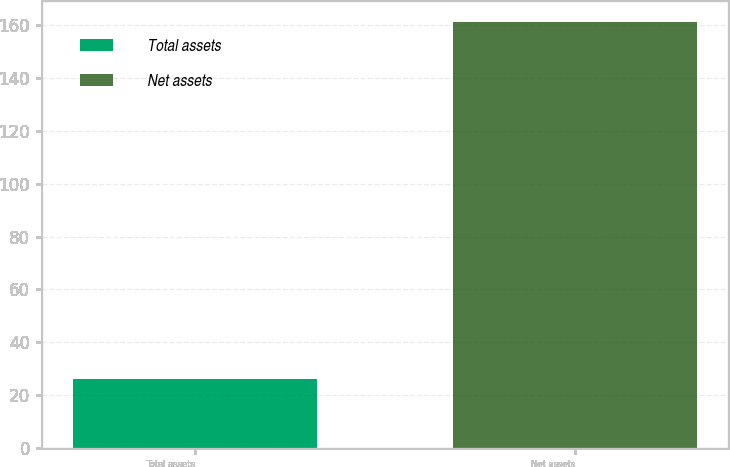<chart> <loc_0><loc_0><loc_500><loc_500><bar_chart><fcel>Total assets<fcel>Net assets<nl><fcel>26<fcel>161<nl></chart> 